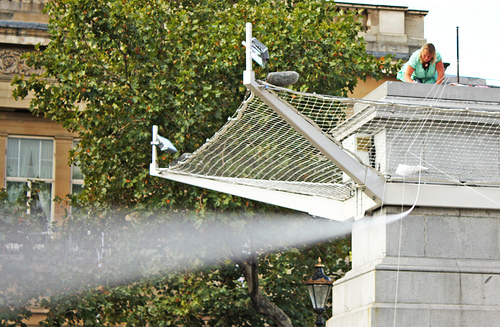<image>
Can you confirm if the woman is behind the tower? No. The woman is not behind the tower. From this viewpoint, the woman appears to be positioned elsewhere in the scene. 